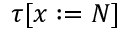Convert formula to latex. <formula><loc_0><loc_0><loc_500><loc_500>\tau [ x \colon = N ]</formula> 